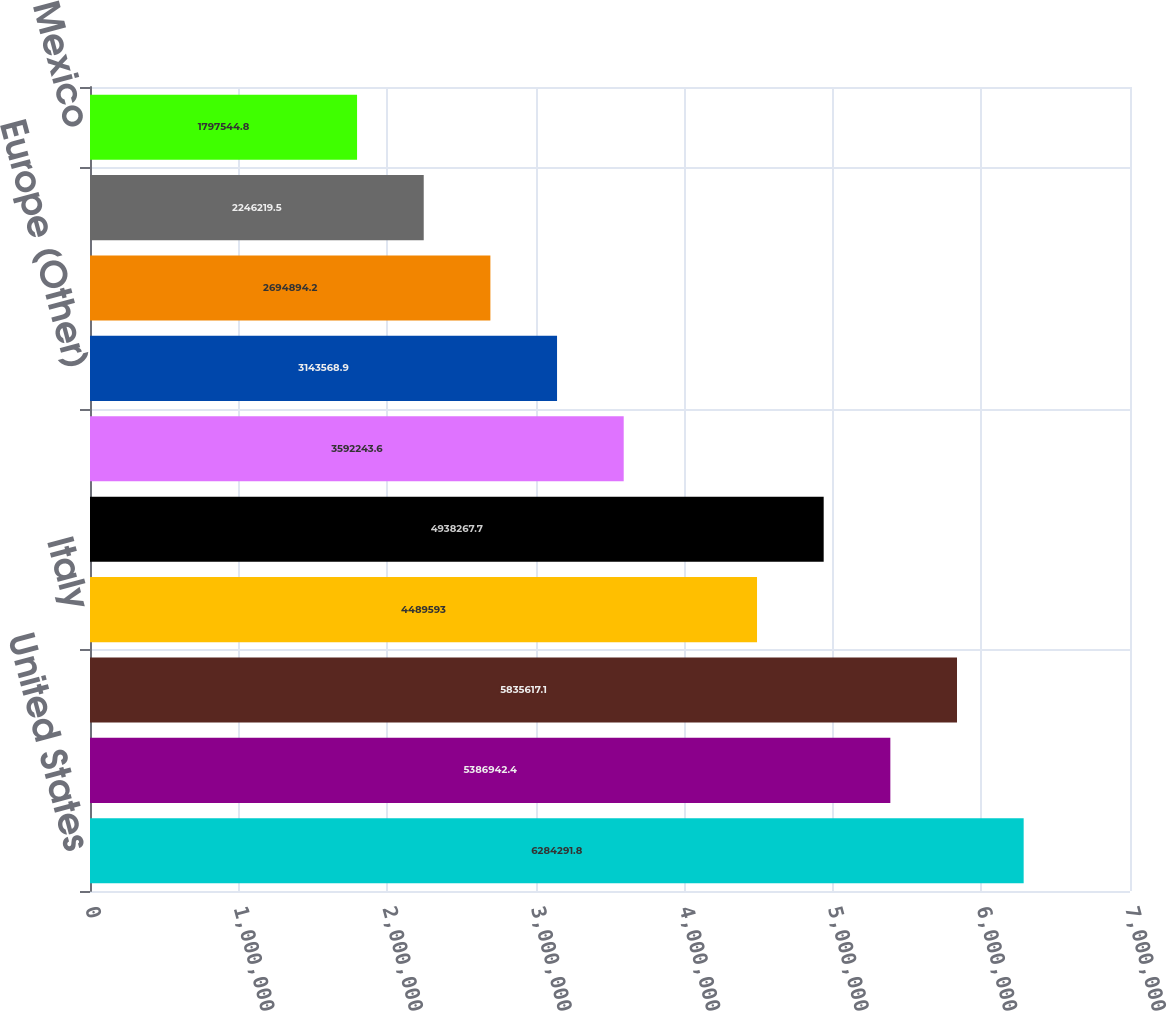Convert chart. <chart><loc_0><loc_0><loc_500><loc_500><bar_chart><fcel>United States<fcel>Australia<fcel>France<fcel>Italy<fcel>Japan<fcel>Germany<fcel>Europe (Other)<fcel>Canada<fcel>Spain<fcel>Mexico<nl><fcel>6.28429e+06<fcel>5.38694e+06<fcel>5.83562e+06<fcel>4.48959e+06<fcel>4.93827e+06<fcel>3.59224e+06<fcel>3.14357e+06<fcel>2.69489e+06<fcel>2.24622e+06<fcel>1.79754e+06<nl></chart> 